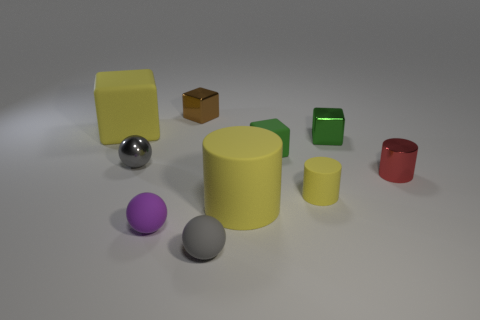How many objects are both in front of the big rubber cylinder and to the right of the small brown shiny cube?
Your answer should be very brief. 1. There is a gray ball that is in front of the small gray object behind the metal cylinder; what is its size?
Offer a very short reply. Small. Is the number of yellow cubes that are in front of the tiny yellow rubber object less than the number of big things that are to the right of the tiny gray rubber object?
Your answer should be compact. Yes. There is a matte object that is to the left of the tiny metal sphere; is its color the same as the tiny cylinder in front of the tiny red object?
Provide a succinct answer. Yes. There is a yellow object that is in front of the tiny red thing and left of the green rubber thing; what material is it?
Give a very brief answer. Rubber. Are any small brown spheres visible?
Provide a succinct answer. No. There is a small green object that is the same material as the tiny red cylinder; what shape is it?
Make the answer very short. Cube. There is a purple thing; does it have the same shape as the large yellow matte object that is in front of the large rubber cube?
Give a very brief answer. No. What is the gray object behind the big rubber object in front of the metal ball made of?
Offer a very short reply. Metal. What number of other things are the same shape as the small red thing?
Make the answer very short. 2. 